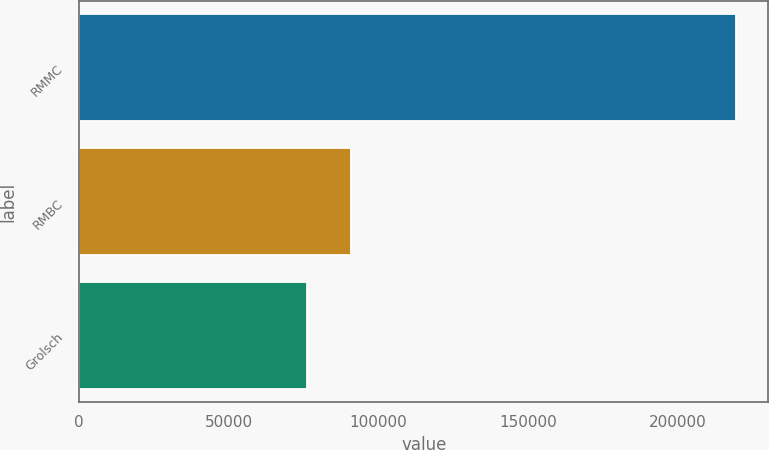Convert chart. <chart><loc_0><loc_0><loc_500><loc_500><bar_chart><fcel>RMMC<fcel>RMBC<fcel>Grolsch<nl><fcel>219365<fcel>90855<fcel>76045<nl></chart> 